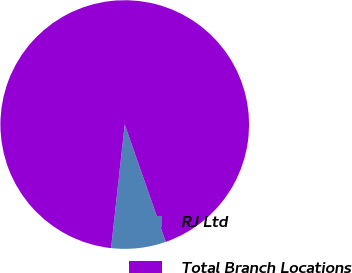Convert chart. <chart><loc_0><loc_0><loc_500><loc_500><pie_chart><fcel>RJ Ltd<fcel>Total Branch Locations<nl><fcel>7.11%<fcel>92.89%<nl></chart> 